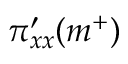<formula> <loc_0><loc_0><loc_500><loc_500>\pi _ { x x } ^ { \prime } ( m ^ { + } )</formula> 